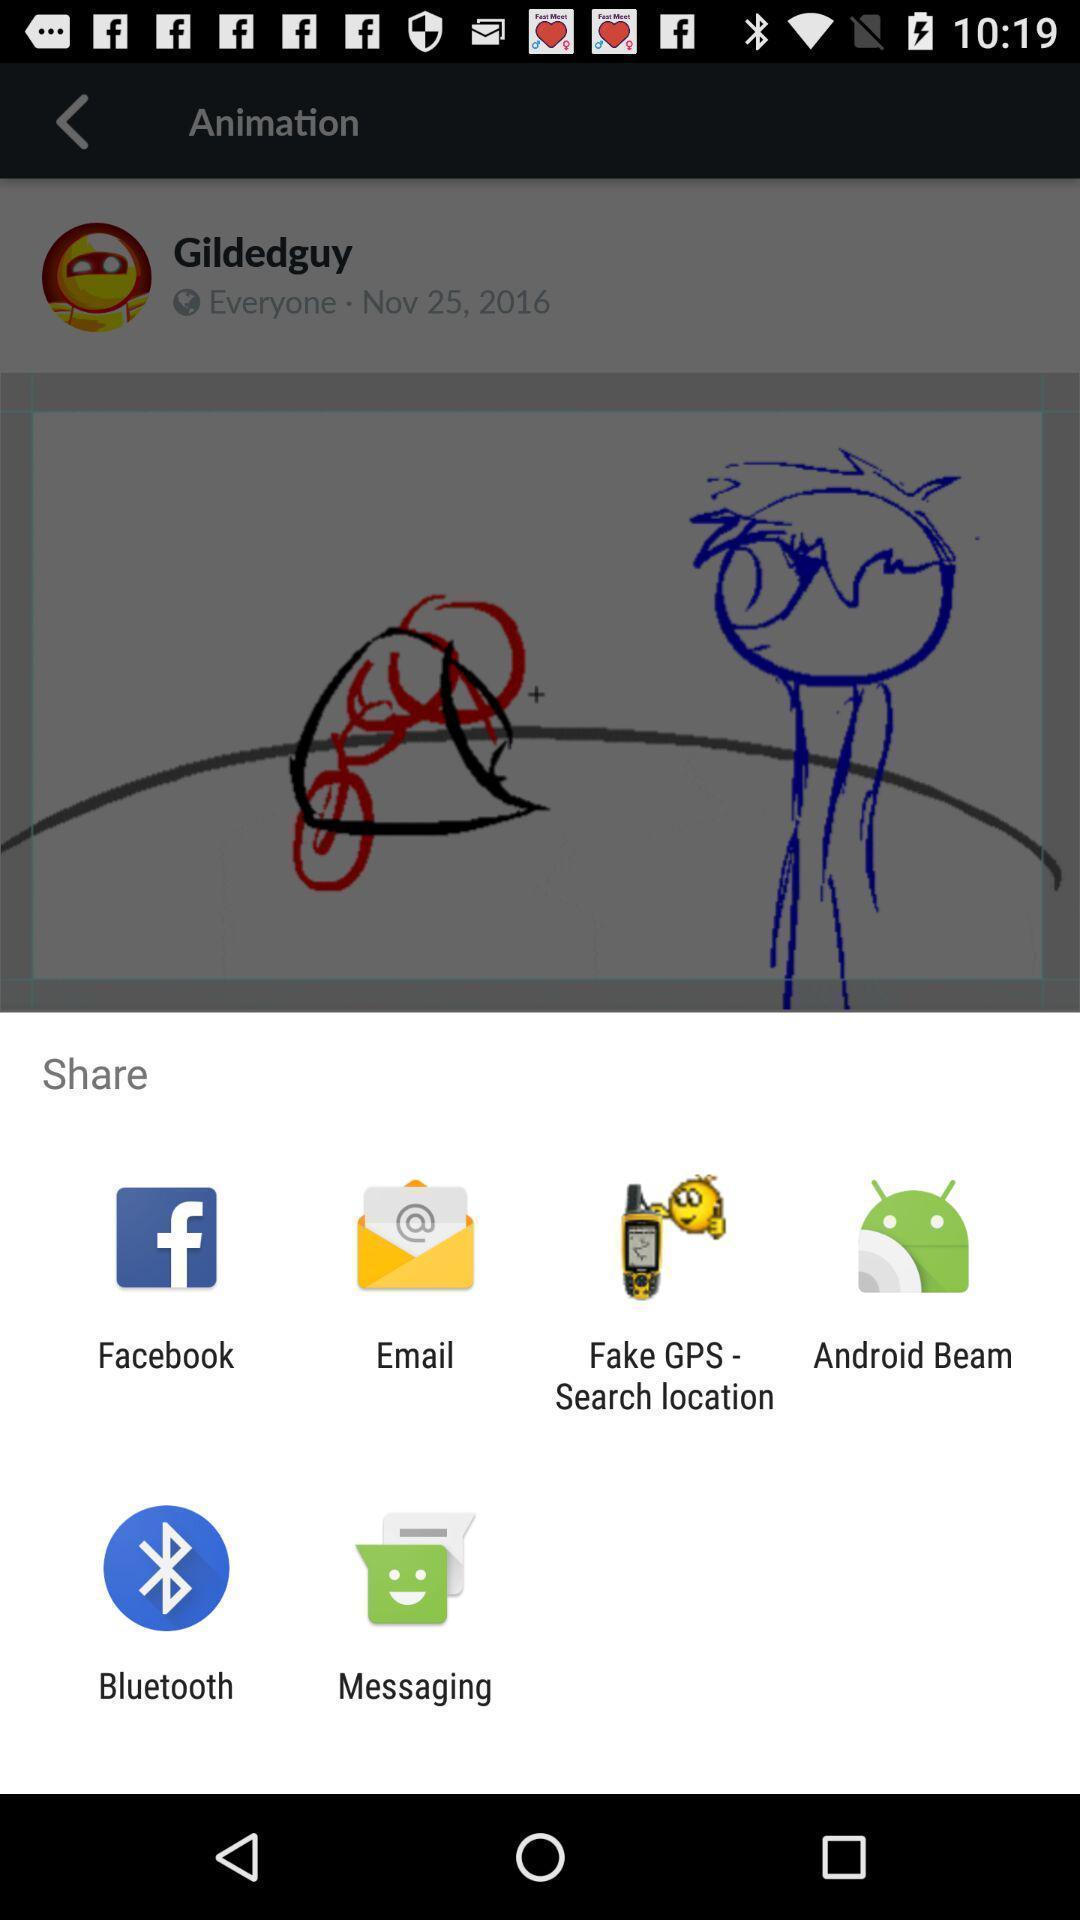Tell me what you see in this picture. Pop-up showing multiple applications to share. 